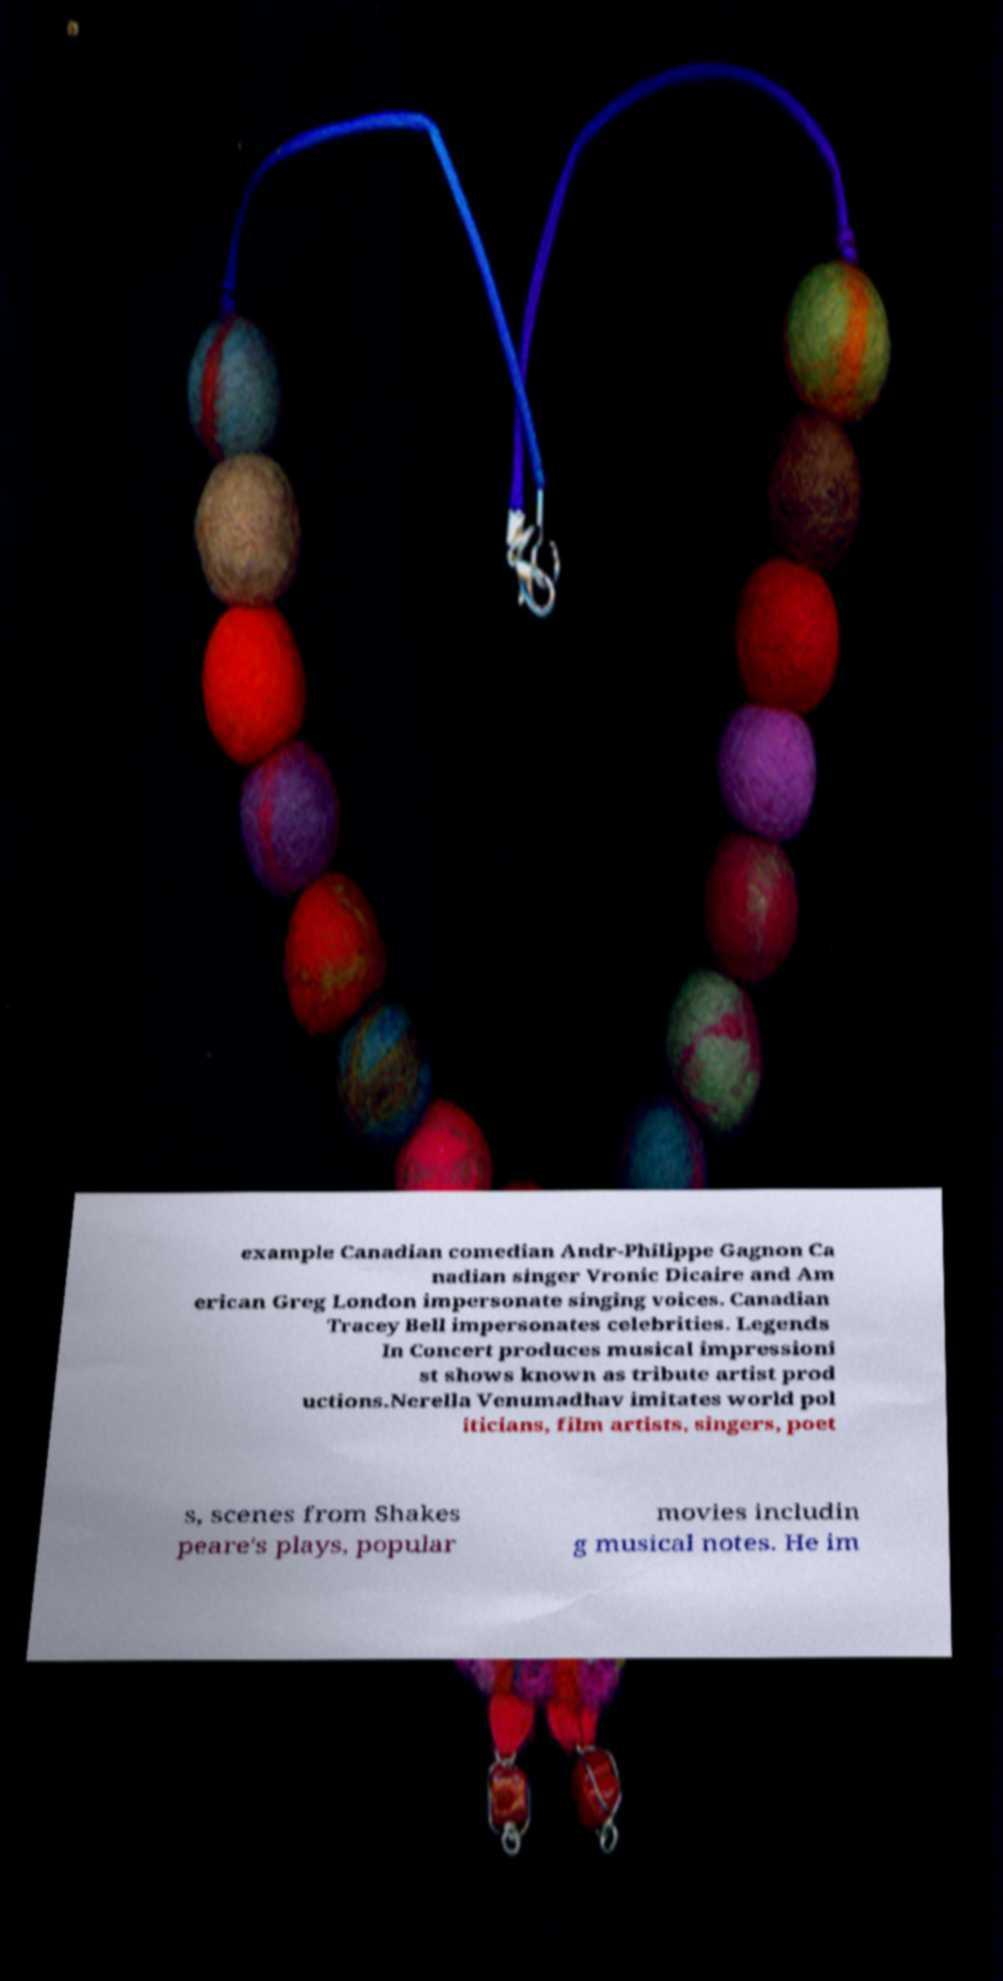Can you read and provide the text displayed in the image?This photo seems to have some interesting text. Can you extract and type it out for me? example Canadian comedian Andr-Philippe Gagnon Ca nadian singer Vronic Dicaire and Am erican Greg London impersonate singing voices. Canadian Tracey Bell impersonates celebrities. Legends In Concert produces musical impressioni st shows known as tribute artist prod uctions.Nerella Venumadhav imitates world pol iticians, film artists, singers, poet s, scenes from Shakes peare's plays, popular movies includin g musical notes. He im 